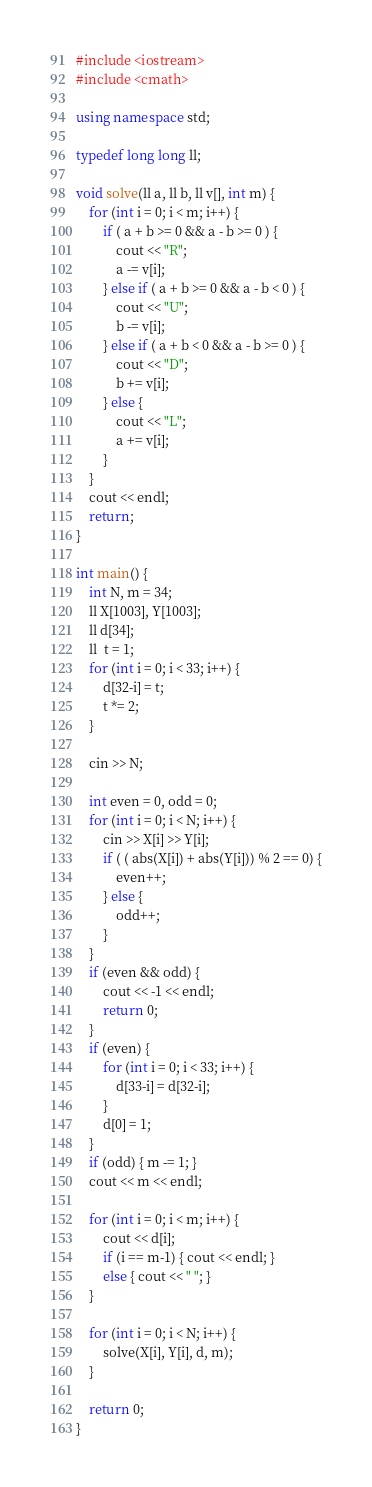Convert code to text. <code><loc_0><loc_0><loc_500><loc_500><_C++_>#include <iostream>
#include <cmath>

using namespace std;

typedef long long ll;

void solve(ll a, ll b, ll v[], int m) {
    for (int i = 0; i < m; i++) {
        if ( a + b >= 0 && a - b >= 0 ) {
            cout << "R";
            a -= v[i];
        } else if ( a + b >= 0 && a - b < 0 ) {
            cout << "U";
            b -= v[i];
        } else if ( a + b < 0 && a - b >= 0 ) {
            cout << "D";
            b += v[i];
        } else {
            cout << "L";
            a += v[i];
        }
    }
    cout << endl;
    return;
}

int main() {
    int N, m = 34;
    ll X[1003], Y[1003];
    ll d[34];
    ll  t = 1;
    for (int i = 0; i < 33; i++) {
        d[32-i] = t;
        t *= 2;
    }

    cin >> N;

    int even = 0, odd = 0;
    for (int i = 0; i < N; i++) {
        cin >> X[i] >> Y[i];
        if ( ( abs(X[i]) + abs(Y[i])) % 2 == 0) {
            even++;
        } else {
            odd++;
        }
    }
    if (even && odd) {
        cout << -1 << endl;
        return 0;
    }
    if (even) {
        for (int i = 0; i < 33; i++) {
            d[33-i] = d[32-i];
        }
        d[0] = 1;
    }
    if (odd) { m -= 1; }
    cout << m << endl;

    for (int i = 0; i < m; i++) {
        cout << d[i];
        if (i == m-1) { cout << endl; }
        else { cout << " "; }
    }

    for (int i = 0; i < N; i++) {
        solve(X[i], Y[i], d, m);
    }

    return 0;
}</code> 